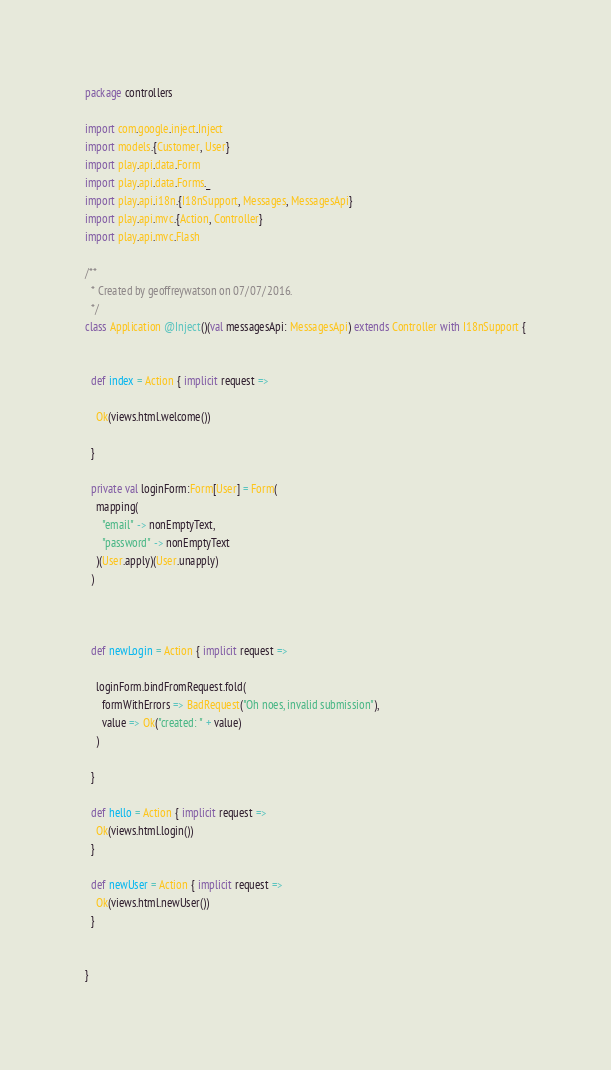Convert code to text. <code><loc_0><loc_0><loc_500><loc_500><_Scala_>package controllers

import com.google.inject.Inject
import models.{Customer, User}
import play.api.data.Form
import play.api.data.Forms._
import play.api.i18n.{I18nSupport, Messages, MessagesApi}
import play.api.mvc.{Action, Controller}
import play.api.mvc.Flash

/**
  * Created by geoffreywatson on 07/07/2016.
  */
class Application @Inject()(val messagesApi: MessagesApi) extends Controller with I18nSupport {


  def index = Action { implicit request =>

    Ok(views.html.welcome())

  }

  private val loginForm:Form[User] = Form(
    mapping(
      "email" -> nonEmptyText,
      "password" -> nonEmptyText
    )(User.apply)(User.unapply)
  )



  def newLogin = Action { implicit request =>

    loginForm.bindFromRequest.fold(
      formWithErrors => BadRequest("Oh noes, invalid submission"),
      value => Ok("created: " + value)
    )

  }

  def hello = Action { implicit request =>
    Ok(views.html.login())
  }

  def newUser = Action { implicit request =>
    Ok(views.html.newUser())
  }


}
</code> 